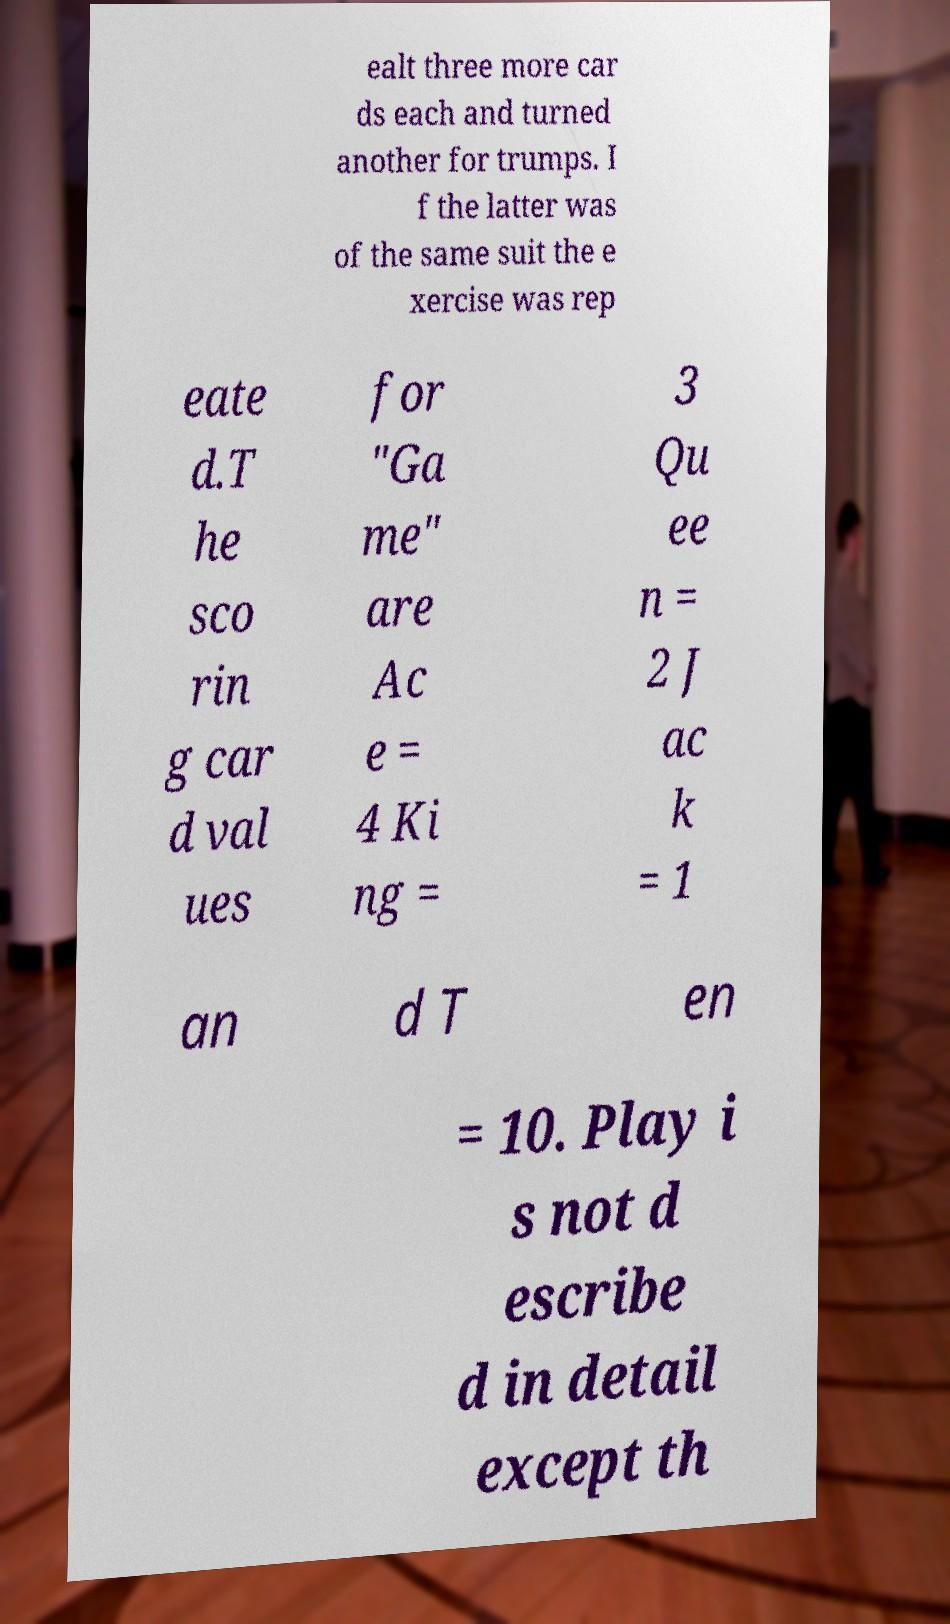Can you read and provide the text displayed in the image?This photo seems to have some interesting text. Can you extract and type it out for me? ealt three more car ds each and turned another for trumps. I f the latter was of the same suit the e xercise was rep eate d.T he sco rin g car d val ues for "Ga me" are Ac e = 4 Ki ng = 3 Qu ee n = 2 J ac k = 1 an d T en = 10. Play i s not d escribe d in detail except th 